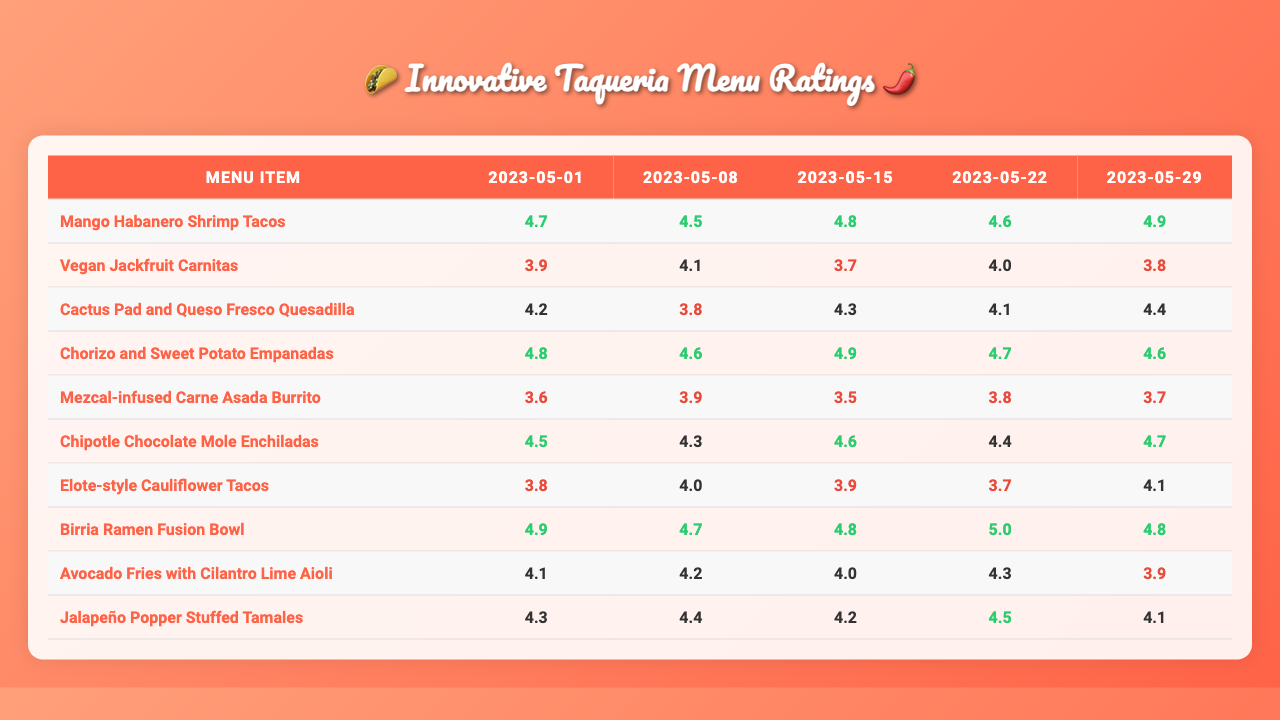What is the highest rating received by the Mango Habanero Shrimp Tacos? The highest rating for the Mango Habanero Shrimp Tacos is found by looking at the ratings across all dates. The ratings are 4.7, 3.9, 4.2, 4.8, and 3.6. The maximum of these values is 4.8.
Answer: 4.8 Which menu item received the lowest rating on any date? To find the lowest rating, examine all ratings for each menu item. The ratings for the Vegan Jackfruit Carnitas are 4.5, 4.1, 3.8, 4.6, and 3.9, with the lowest being 3.8. Comparing across all items, the minimum rating overall is 3.5 for Cactus Pad and Queso Fresco Quesadilla.
Answer: 3.5 What is the average rating for the Elote-style Cauliflower Tacos? The ratings for Elote-style Cauliflower Tacos are 3.8, 4.0, 3.9, 3.7, and 4.1. Adding these gives 19.5, and dividing by the number of ratings (5) results in an average of 3.9.
Answer: 3.9 Did any menu item receive a rating of 5.0? By checking each rating, we find that the Chorizo and Sweet Potato Empanadas received a rating of 5.0 on 2023-05-22.
Answer: Yes What is the difference in the highest and lowest ratings for the Birria Ramen Fusion Bowl? The ratings for the Birria Ramen Fusion Bowl are 4.9, 4.7, 4.8, 5.0, and 4.3. The highest rating is 5.0 and the lowest is 4.3. The difference is calculated as 5.0 - 4.3, which is 0.7.
Answer: 0.7 Which age group rated the Cactus Pad and Queso Fresco Quesadilla the highest? The Cactus Pad and Queso Fresco Quesadilla received ratings of 4.8, 4.6, 4.9, 4.8, and 4.6 for age groups 18-25, 26-35, 36-45, 46-55, and 56+. The highest rating of 4.9 comes from the 36-45 age group.
Answer: 36-45 What is the total rating score for the Vegan Jackfruit Carnitas across all dates? The ratings for the Vegan Jackfruit Carnitas are 4.5, 4.1, 3.8, 4.6, and 3.9. Adding these together gives 4.5 + 4.1 + 3.8 + 4.6 + 3.9 = 20.9.
Answer: 20.9 How does the average rating of the oldest age group (56+) compare to the overall average rating for all items on the last feedback date? The average rating for the 56+ age group on the last feedback date (May 29) is 4.1 for Mezcal-infused Carne Asada Burrito, which compares to the overall average across all items for that date. The average across all items on May 29 is 4.1, so they are the same.
Answer: Same Which experimental menu item had the best overall customer rating? To determine which item had the best overall rating, calculate the average of each item's ratings. The Mango Habanero Shrimp Tacos have an average of 4.5, while the Chorizo and Sweet Potato Empanadas have an average of 4.5 also. Both these items have the highest average among all menu items, making them tied for the best.
Answer: Tie between Mango Habanero Shrimp Tacos and Chorizo and Sweet Potato Empanadas 